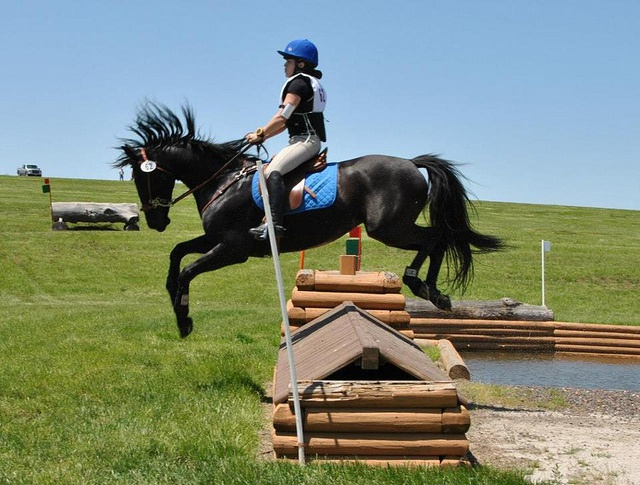Describe the objects in this image and their specific colors. I can see horse in lightblue, black, gray, darkgreen, and olive tones, horse in lightblue, black, and gray tones, people in lightblue, black, gray, lightgray, and darkgray tones, truck in lightblue, gray, black, darkgray, and blue tones, and people in lightblue, darkgray, gray, and lavender tones in this image. 